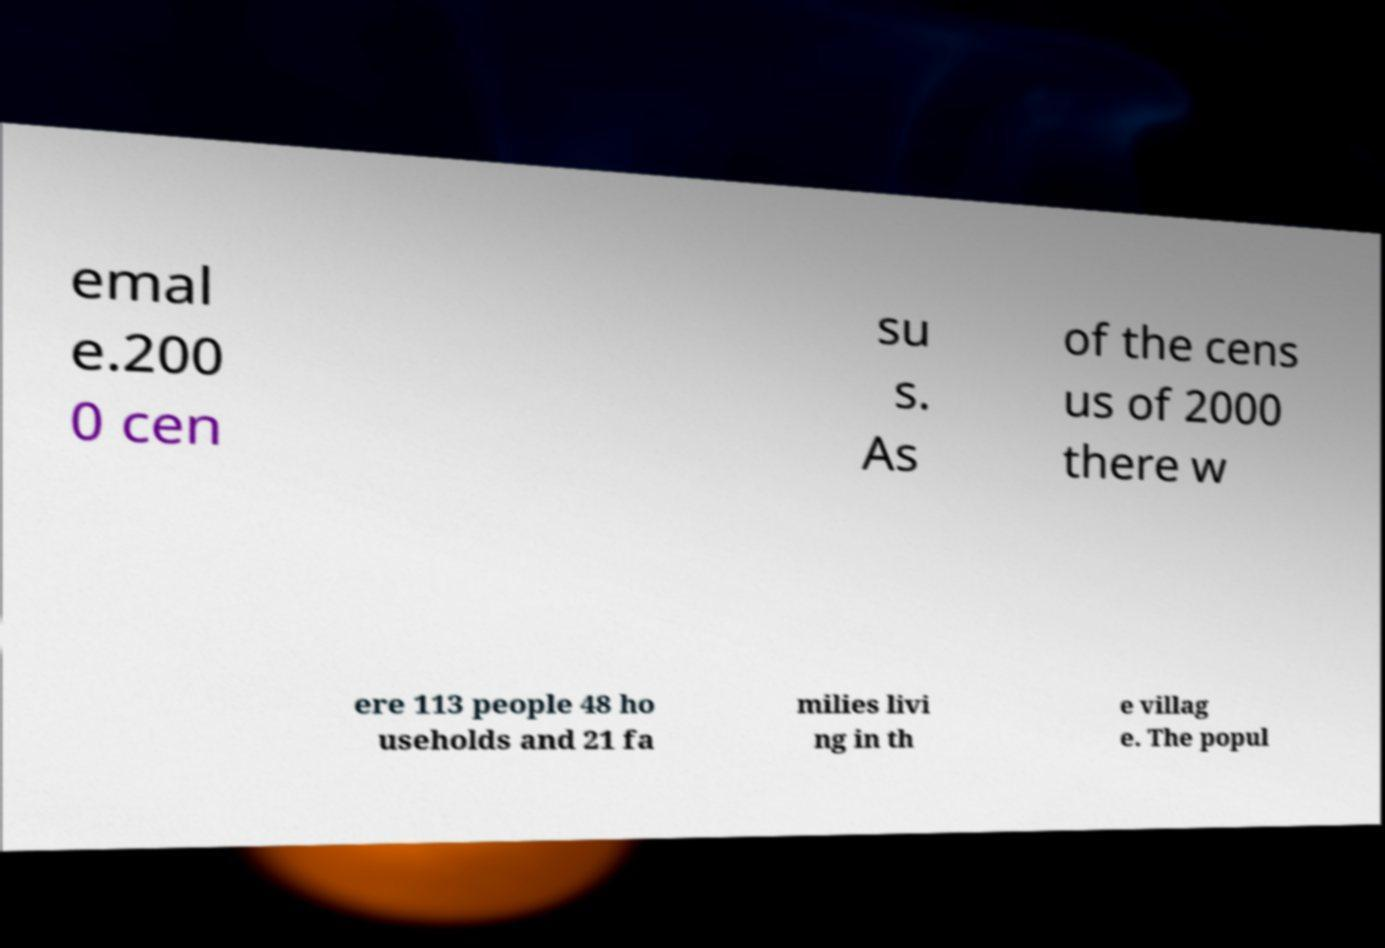Can you accurately transcribe the text from the provided image for me? emal e.200 0 cen su s. As of the cens us of 2000 there w ere 113 people 48 ho useholds and 21 fa milies livi ng in th e villag e. The popul 